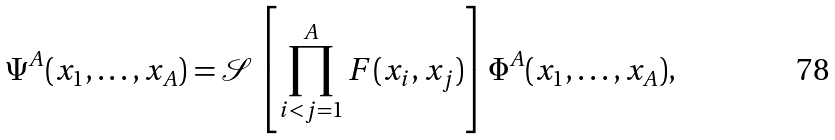Convert formula to latex. <formula><loc_0><loc_0><loc_500><loc_500>\Psi ^ { A } ( x _ { 1 } , \dots , x _ { A } ) = \mathcal { S } \left [ \prod _ { i < j = 1 } ^ { A } F ( x _ { i } , x _ { j } ) \right ] \Phi ^ { A } ( x _ { 1 } , \dots , x _ { A } ) ,</formula> 